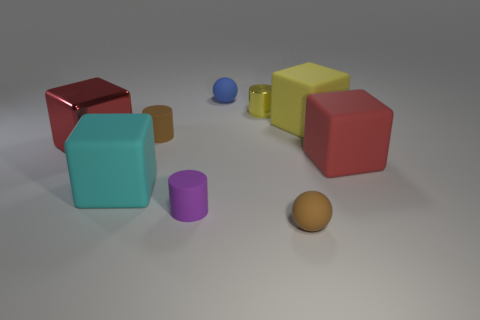Subtract all tiny brown cylinders. How many cylinders are left? 2 Subtract all gray spheres. How many red blocks are left? 2 Subtract 1 cylinders. How many cylinders are left? 2 Subtract all cyan blocks. How many blocks are left? 3 Add 1 yellow matte blocks. How many objects exist? 10 Subtract all spheres. How many objects are left? 7 Subtract all brown cubes. Subtract all cyan cylinders. How many cubes are left? 4 Subtract 0 purple cubes. How many objects are left? 9 Subtract all tiny gray things. Subtract all purple rubber objects. How many objects are left? 8 Add 2 cyan rubber things. How many cyan rubber things are left? 3 